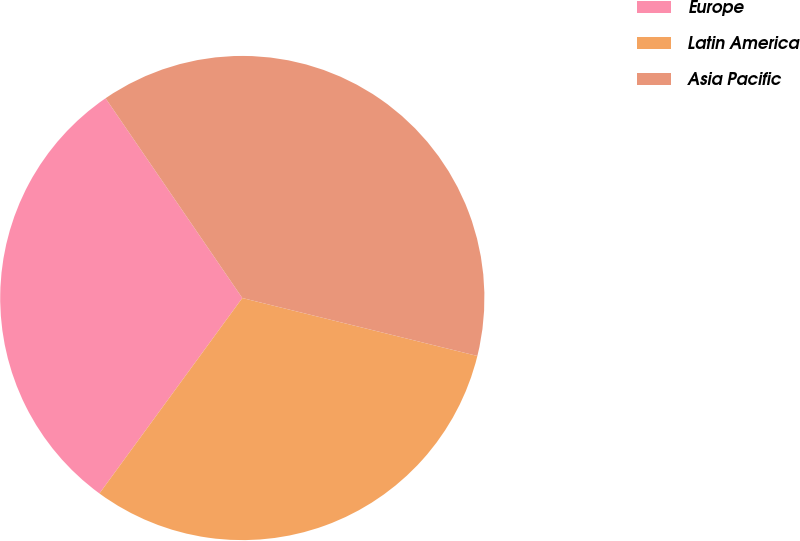<chart> <loc_0><loc_0><loc_500><loc_500><pie_chart><fcel>Europe<fcel>Latin America<fcel>Asia Pacific<nl><fcel>30.4%<fcel>31.2%<fcel>38.4%<nl></chart> 